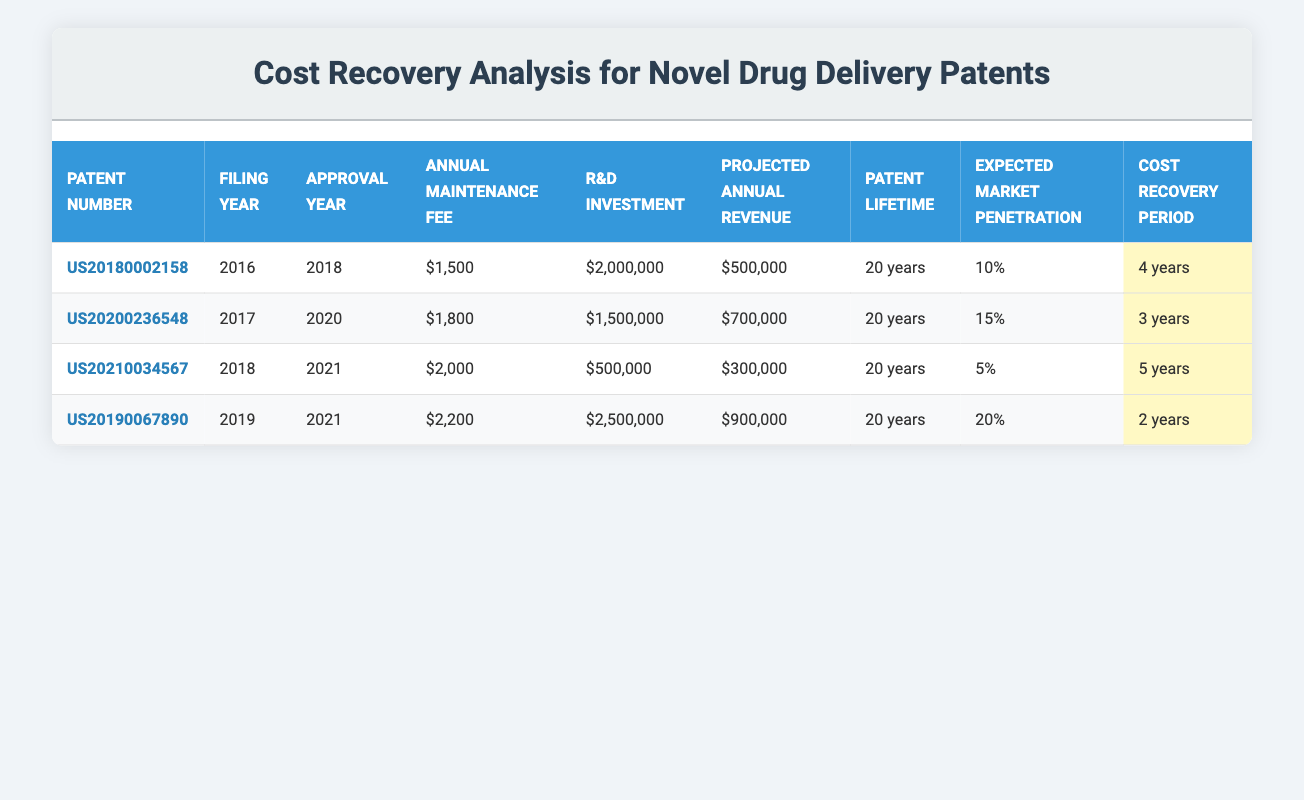What is the annual maintenance fee for Patent US20210034567? The table lists the annual maintenance fee for Patent US20210034567 in the corresponding column, which is $2,000.
Answer: $2,000 Which patent has the highest projected annual revenue? By examining the "Projected Annual Revenue" column, we see that US20190067890 has a projected annual revenue of $900,000, which is higher than any other patent in the list.
Answer: US20190067890 What is the total R&D investment for all patents? The total R&D investment is calculated by adding up all R&D investments: $2,000,000 + $1,500,000 + $500,000 + $2,500,000 = $6,500,000.
Answer: $6,500,000 Is the expected market penetration for Patent US20200236548 greater than 10%? The expected market penetration for US20200236548 is 15%, which is greater than 10%, confirming the statement is true.
Answer: Yes Which patent has the longest cost recovery period, and what is it? To find the longest cost recovery period, we look at the "Cost Recovery Period" column and identify that US20210034567 has a period of 5 years, which is the longest among all patents listed.
Answer: US20210034567, 5 years What is the average annual maintenance fee for all patents? To calculate the average, we add the annual maintenance fees: $1,500 + $1,800 + $2,000 + $2,200 = $7,500. Dividing this total by the number of patents (4), we find the average is $1,875.
Answer: $1,875 Which patent has the lowest projected annual revenue? The "Projected Annual Revenue" for Patent US20210034567 is $300,000, which is less than that of the other patents on the list, indicating it has the lowest projected revenue.
Answer: US20210034567 Is Patent US20190067890 expected to recover costs in less than 3 years? The cost recovery period for Patent US20190067890 is 2 years, which is indeed less than 3 years, affirming that the statement is true.
Answer: Yes What is the median expected market penetration across all patents? Listing the expected market penetrations (5%, 10%, 15%, 20%), we arrange them to get the median, which is the average of the two middle values (10% and 15%). Therefore, the median expected market penetration is (10% + 15%) / 2 = 12.5%.
Answer: 12.5% 